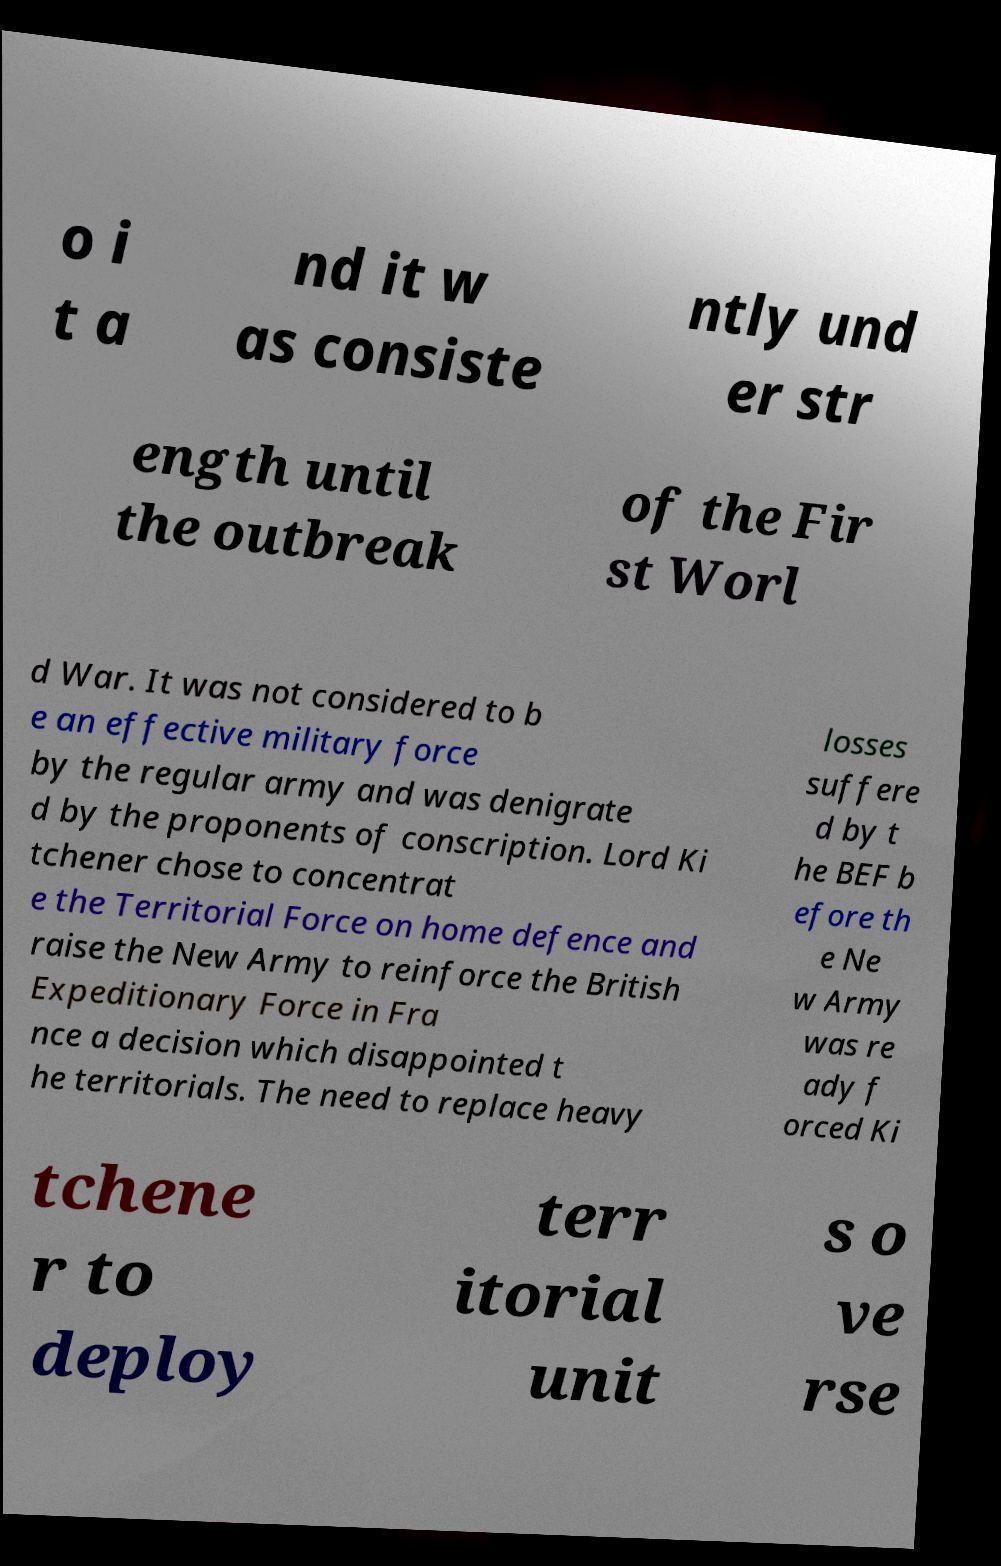Please read and relay the text visible in this image. What does it say? o i t a nd it w as consiste ntly und er str ength until the outbreak of the Fir st Worl d War. It was not considered to b e an effective military force by the regular army and was denigrate d by the proponents of conscription. Lord Ki tchener chose to concentrat e the Territorial Force on home defence and raise the New Army to reinforce the British Expeditionary Force in Fra nce a decision which disappointed t he territorials. The need to replace heavy losses suffere d by t he BEF b efore th e Ne w Army was re ady f orced Ki tchene r to deploy terr itorial unit s o ve rse 